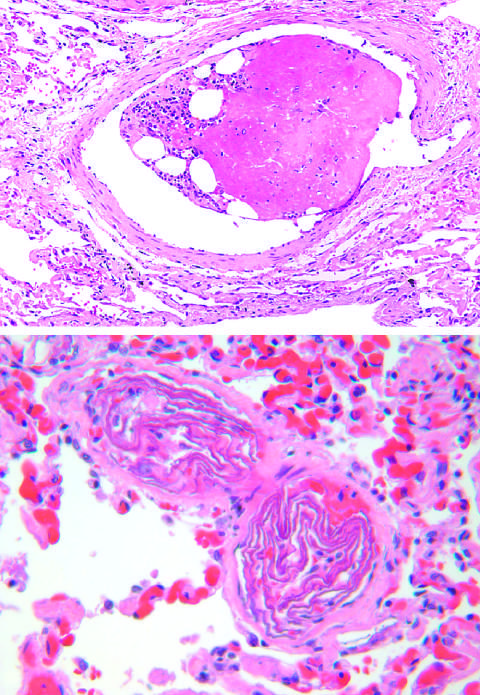what are packed with laminated swirls of fetal squamous cells?
Answer the question using a single word or phrase. Two small pulmonary arterioles 